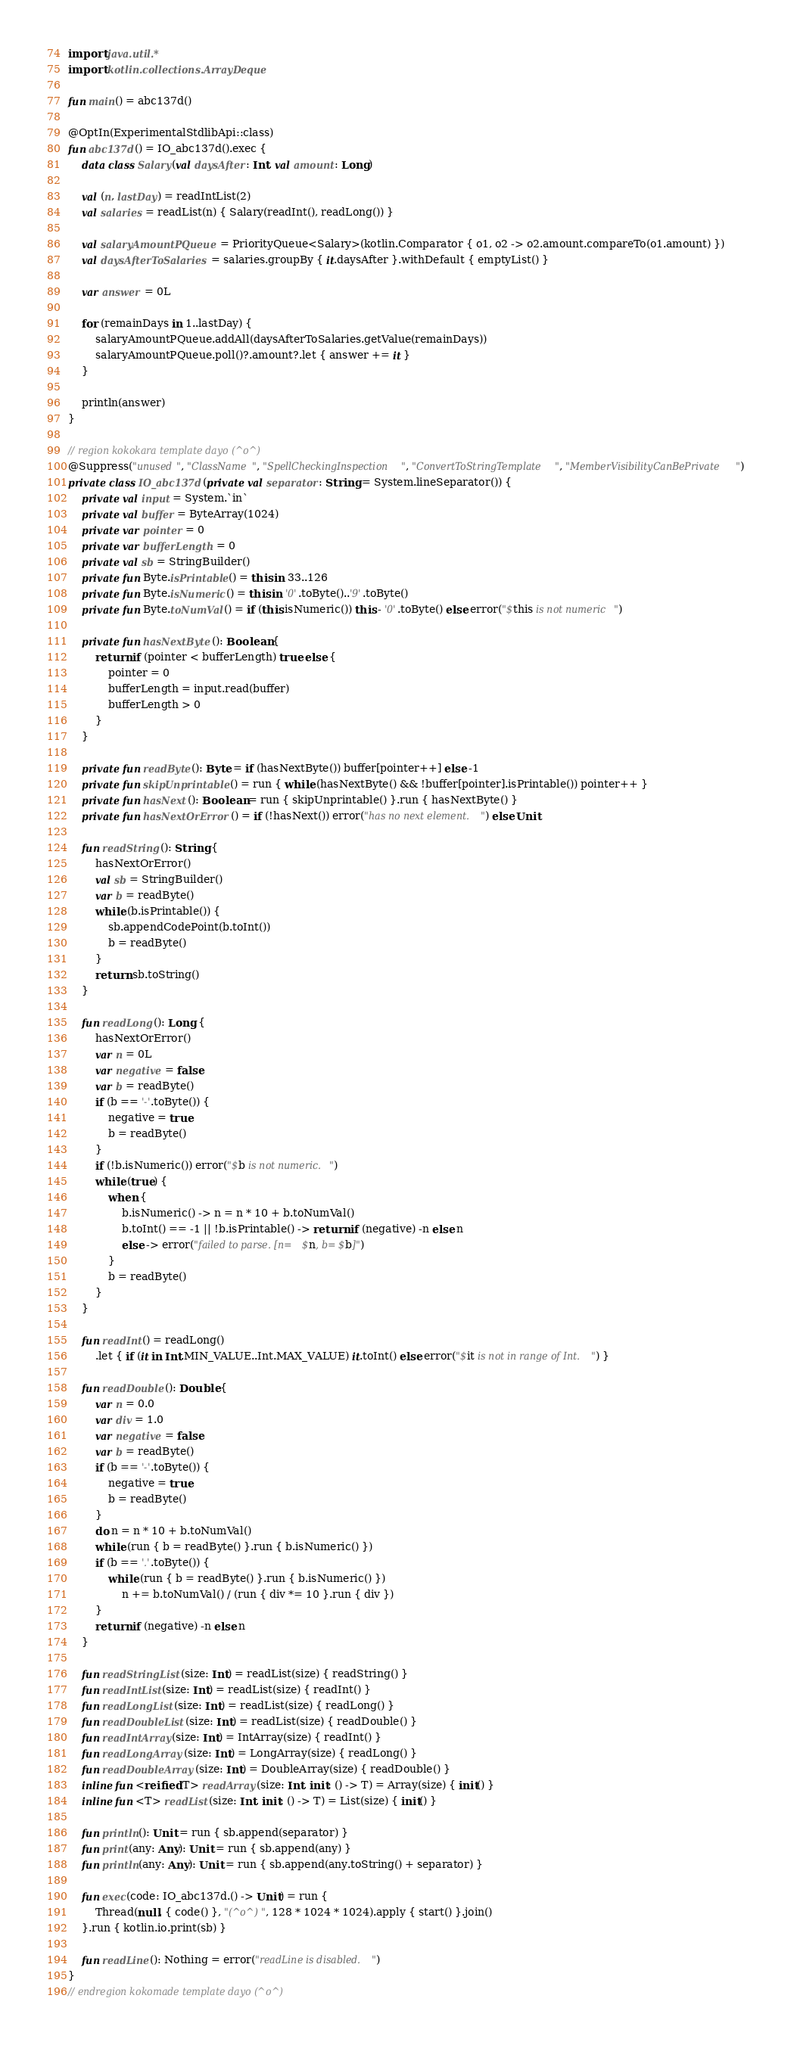<code> <loc_0><loc_0><loc_500><loc_500><_Kotlin_>import java.util.*
import kotlin.collections.ArrayDeque

fun main() = abc137d()

@OptIn(ExperimentalStdlibApi::class)
fun abc137d() = IO_abc137d().exec {
    data class Salary(val daysAfter: Int, val amount: Long)

    val (n, lastDay) = readIntList(2)
    val salaries = readList(n) { Salary(readInt(), readLong()) }

    val salaryAmountPQueue = PriorityQueue<Salary>(kotlin.Comparator { o1, o2 -> o2.amount.compareTo(o1.amount) })
    val daysAfterToSalaries = salaries.groupBy { it.daysAfter }.withDefault { emptyList() }

    var answer = 0L

    for (remainDays in 1..lastDay) {
        salaryAmountPQueue.addAll(daysAfterToSalaries.getValue(remainDays))
        salaryAmountPQueue.poll()?.amount?.let { answer += it }
    }

    println(answer)
}

// region kokokara template dayo (^o^)
@Suppress("unused", "ClassName", "SpellCheckingInspection", "ConvertToStringTemplate", "MemberVisibilityCanBePrivate")
private class IO_abc137d(private val separator: String = System.lineSeparator()) {
    private val input = System.`in`
    private val buffer = ByteArray(1024)
    private var pointer = 0
    private var bufferLength = 0
    private val sb = StringBuilder()
    private fun Byte.isPrintable() = this in 33..126
    private fun Byte.isNumeric() = this in '0'.toByte()..'9'.toByte()
    private fun Byte.toNumVal() = if (this.isNumeric()) this - '0'.toByte() else error("$this is not numeric")

    private fun hasNextByte(): Boolean {
        return if (pointer < bufferLength) true else {
            pointer = 0
            bufferLength = input.read(buffer)
            bufferLength > 0
        }
    }

    private fun readByte(): Byte = if (hasNextByte()) buffer[pointer++] else -1
    private fun skipUnprintable() = run { while (hasNextByte() && !buffer[pointer].isPrintable()) pointer++ }
    private fun hasNext(): Boolean = run { skipUnprintable() }.run { hasNextByte() }
    private fun hasNextOrError() = if (!hasNext()) error("has no next element.") else Unit

    fun readString(): String {
        hasNextOrError()
        val sb = StringBuilder()
        var b = readByte()
        while (b.isPrintable()) {
            sb.appendCodePoint(b.toInt())
            b = readByte()
        }
        return sb.toString()
    }

    fun readLong(): Long {
        hasNextOrError()
        var n = 0L
        var negative = false
        var b = readByte()
        if (b == '-'.toByte()) {
            negative = true
            b = readByte()
        }
        if (!b.isNumeric()) error("$b is not numeric.")
        while (true) {
            when {
                b.isNumeric() -> n = n * 10 + b.toNumVal()
                b.toInt() == -1 || !b.isPrintable() -> return if (negative) -n else n
                else -> error("failed to parse. [n=$n, b=$b]")
            }
            b = readByte()
        }
    }

    fun readInt() = readLong()
        .let { if (it in Int.MIN_VALUE..Int.MAX_VALUE) it.toInt() else error("$it is not in range of Int.") }

    fun readDouble(): Double {
        var n = 0.0
        var div = 1.0
        var negative = false
        var b = readByte()
        if (b == '-'.toByte()) {
            negative = true
            b = readByte()
        }
        do n = n * 10 + b.toNumVal()
        while (run { b = readByte() }.run { b.isNumeric() })
        if (b == '.'.toByte()) {
            while (run { b = readByte() }.run { b.isNumeric() })
                n += b.toNumVal() / (run { div *= 10 }.run { div })
        }
        return if (negative) -n else n
    }

    fun readStringList(size: Int) = readList(size) { readString() }
    fun readIntList(size: Int) = readList(size) { readInt() }
    fun readLongList(size: Int) = readList(size) { readLong() }
    fun readDoubleList(size: Int) = readList(size) { readDouble() }
    fun readIntArray(size: Int) = IntArray(size) { readInt() }
    fun readLongArray(size: Int) = LongArray(size) { readLong() }
    fun readDoubleArray(size: Int) = DoubleArray(size) { readDouble() }
    inline fun <reified T> readArray(size: Int, init: () -> T) = Array(size) { init() }
    inline fun <T> readList(size: Int, init: () -> T) = List(size) { init() }

    fun println(): Unit = run { sb.append(separator) }
    fun print(any: Any): Unit = run { sb.append(any) }
    fun println(any: Any): Unit = run { sb.append(any.toString() + separator) }

    fun exec(code: IO_abc137d.() -> Unit) = run {
        Thread(null, { code() }, "(^o^)", 128 * 1024 * 1024).apply { start() }.join()
    }.run { kotlin.io.print(sb) }

    fun readLine(): Nothing = error("readLine is disabled.")
}
// endregion kokomade template dayo (^o^)
</code> 